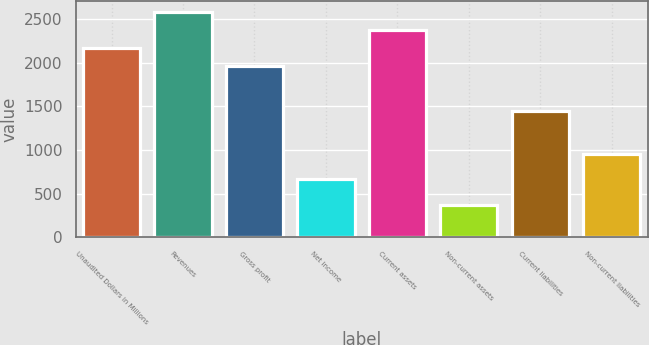<chart> <loc_0><loc_0><loc_500><loc_500><bar_chart><fcel>Unaudited Dollars in Millions<fcel>Revenues<fcel>Gross profit<fcel>Net income<fcel>Current assets<fcel>Non-current assets<fcel>Current liabilities<fcel>Non-current liabilities<nl><fcel>2170.6<fcel>2581.8<fcel>1965<fcel>673<fcel>2376.2<fcel>371<fcel>1447<fcel>949<nl></chart> 